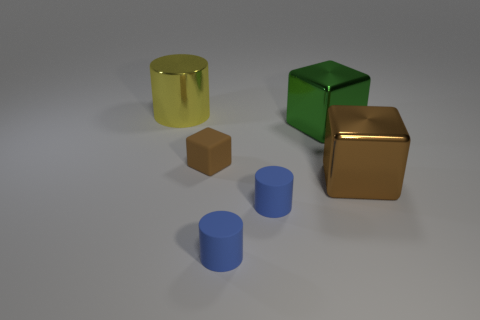The green cube that is the same material as the big cylinder is what size?
Make the answer very short. Large. There is a brown metal object; does it have the same size as the shiny cube that is left of the brown metal cube?
Provide a short and direct response. Yes. There is a yellow thing on the left side of the large brown metal thing; what material is it?
Your answer should be very brief. Metal. What number of large brown metal cubes are to the right of the big brown object in front of the green block?
Provide a succinct answer. 0. Is the size of the cube right of the green metal thing the same as the cylinder that is behind the green block?
Offer a terse response. Yes. There is a big object that is behind the big shiny block behind the small brown object; what is its shape?
Provide a succinct answer. Cylinder. Is there anything else that has the same color as the tiny rubber block?
Provide a succinct answer. Yes. The brown object that is the same material as the green block is what shape?
Your answer should be compact. Cube. There is a large metallic block that is behind the small matte object that is behind the cube in front of the brown matte cube; what is its color?
Ensure brevity in your answer.  Green. Is the color of the small block the same as the object to the right of the large green shiny cube?
Your answer should be compact. Yes. 